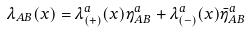<formula> <loc_0><loc_0><loc_500><loc_500>\lambda _ { A B } ( x ) = \lambda ^ { a } _ { ( + ) } ( x ) \eta ^ { a } _ { A B } + \lambda ^ { a } _ { ( - ) } ( x ) \bar { \eta } ^ { a } _ { A B }</formula> 